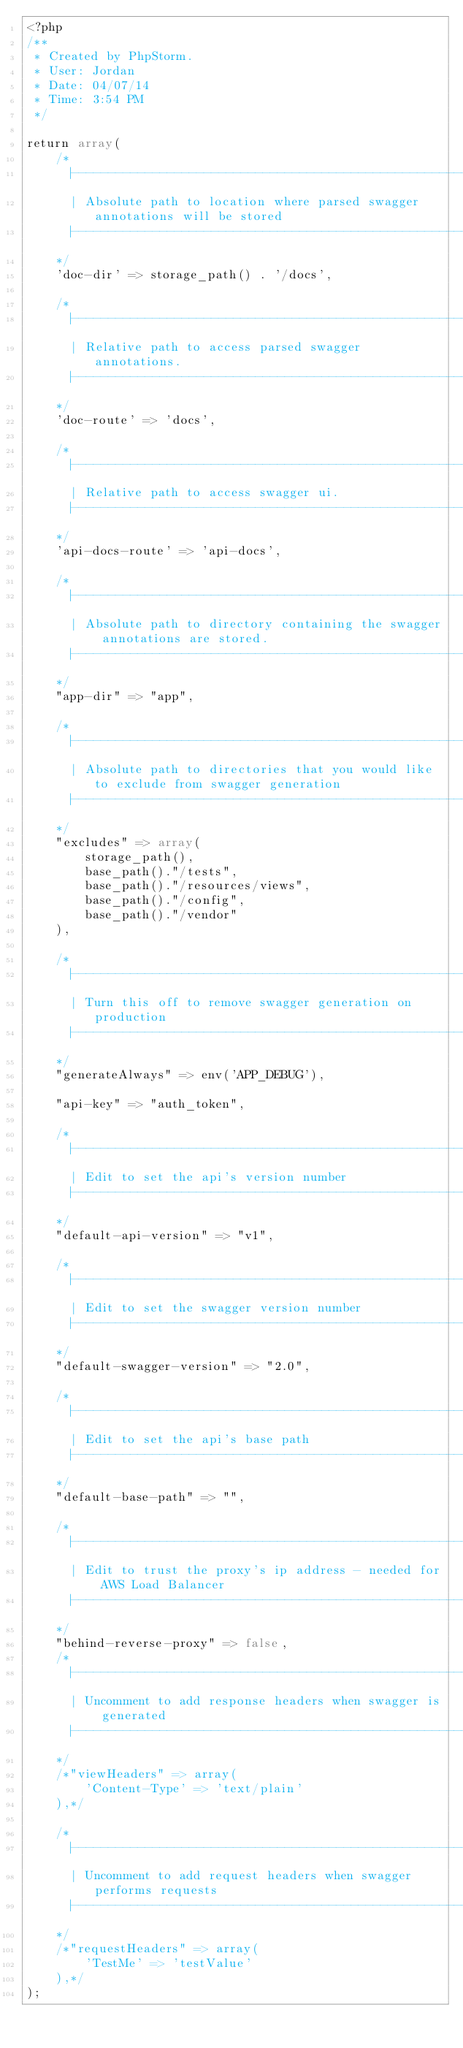Convert code to text. <code><loc_0><loc_0><loc_500><loc_500><_PHP_><?php
/**
 * Created by PhpStorm.
 * User: Jordan
 * Date: 04/07/14
 * Time: 3:54 PM
 */

return array(
    /*
      |--------------------------------------------------------------------------
      | Absolute path to location where parsed swagger annotations will be stored
      |--------------------------------------------------------------------------
    */
    'doc-dir' => storage_path() . '/docs',

    /*
      |--------------------------------------------------------------------------
      | Relative path to access parsed swagger annotations.
      |--------------------------------------------------------------------------
    */
    'doc-route' => 'docs',

    /*
      |--------------------------------------------------------------------------
      | Relative path to access swagger ui.
      |--------------------------------------------------------------------------
    */
    'api-docs-route' => 'api-docs',

    /*
      |--------------------------------------------------------------------------
      | Absolute path to directory containing the swagger annotations are stored.
      |--------------------------------------------------------------------------
    */
    "app-dir" => "app",

    /*
      |--------------------------------------------------------------------------
      | Absolute path to directories that you would like to exclude from swagger generation
      |--------------------------------------------------------------------------
    */
    "excludes" => array(
        storage_path(),
        base_path()."/tests",
        base_path()."/resources/views",
        base_path()."/config",
        base_path()."/vendor"
    ),

    /*
      |--------------------------------------------------------------------------
      | Turn this off to remove swagger generation on production
      |--------------------------------------------------------------------------
    */
    "generateAlways" => env('APP_DEBUG'),

    "api-key" => "auth_token",

    /*
      |--------------------------------------------------------------------------
      | Edit to set the api's version number
      |--------------------------------------------------------------------------
    */
    "default-api-version" => "v1",

    /*
      |--------------------------------------------------------------------------
      | Edit to set the swagger version number
      |--------------------------------------------------------------------------
    */
    "default-swagger-version" => "2.0",

    /*
      |--------------------------------------------------------------------------
      | Edit to set the api's base path
      |--------------------------------------------------------------------------
    */
    "default-base-path" => "",

    /*
      |--------------------------------------------------------------------------
      | Edit to trust the proxy's ip address - needed for AWS Load Balancer
      |--------------------------------------------------------------------------
    */
    "behind-reverse-proxy" => false,
    /*
      |--------------------------------------------------------------------------
      | Uncomment to add response headers when swagger is generated
      |--------------------------------------------------------------------------
    */
    /*"viewHeaders" => array(
        'Content-Type' => 'text/plain'
    ),*/

    /*
      |--------------------------------------------------------------------------
      | Uncomment to add request headers when swagger performs requests
      |--------------------------------------------------------------------------
    */
    /*"requestHeaders" => array(
        'TestMe' => 'testValue'
    ),*/
);
</code> 